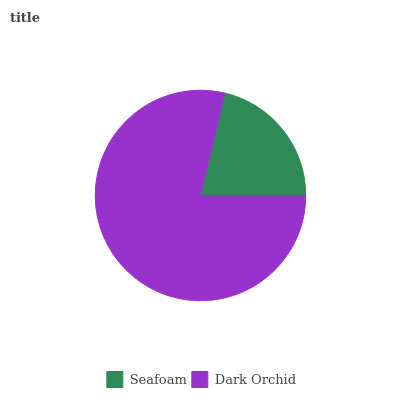Is Seafoam the minimum?
Answer yes or no. Yes. Is Dark Orchid the maximum?
Answer yes or no. Yes. Is Dark Orchid the minimum?
Answer yes or no. No. Is Dark Orchid greater than Seafoam?
Answer yes or no. Yes. Is Seafoam less than Dark Orchid?
Answer yes or no. Yes. Is Seafoam greater than Dark Orchid?
Answer yes or no. No. Is Dark Orchid less than Seafoam?
Answer yes or no. No. Is Dark Orchid the high median?
Answer yes or no. Yes. Is Seafoam the low median?
Answer yes or no. Yes. Is Seafoam the high median?
Answer yes or no. No. Is Dark Orchid the low median?
Answer yes or no. No. 